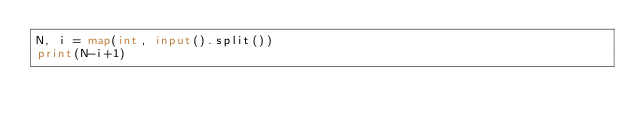Convert code to text. <code><loc_0><loc_0><loc_500><loc_500><_Python_>N, i = map(int, input().split())
print(N-i+1)</code> 